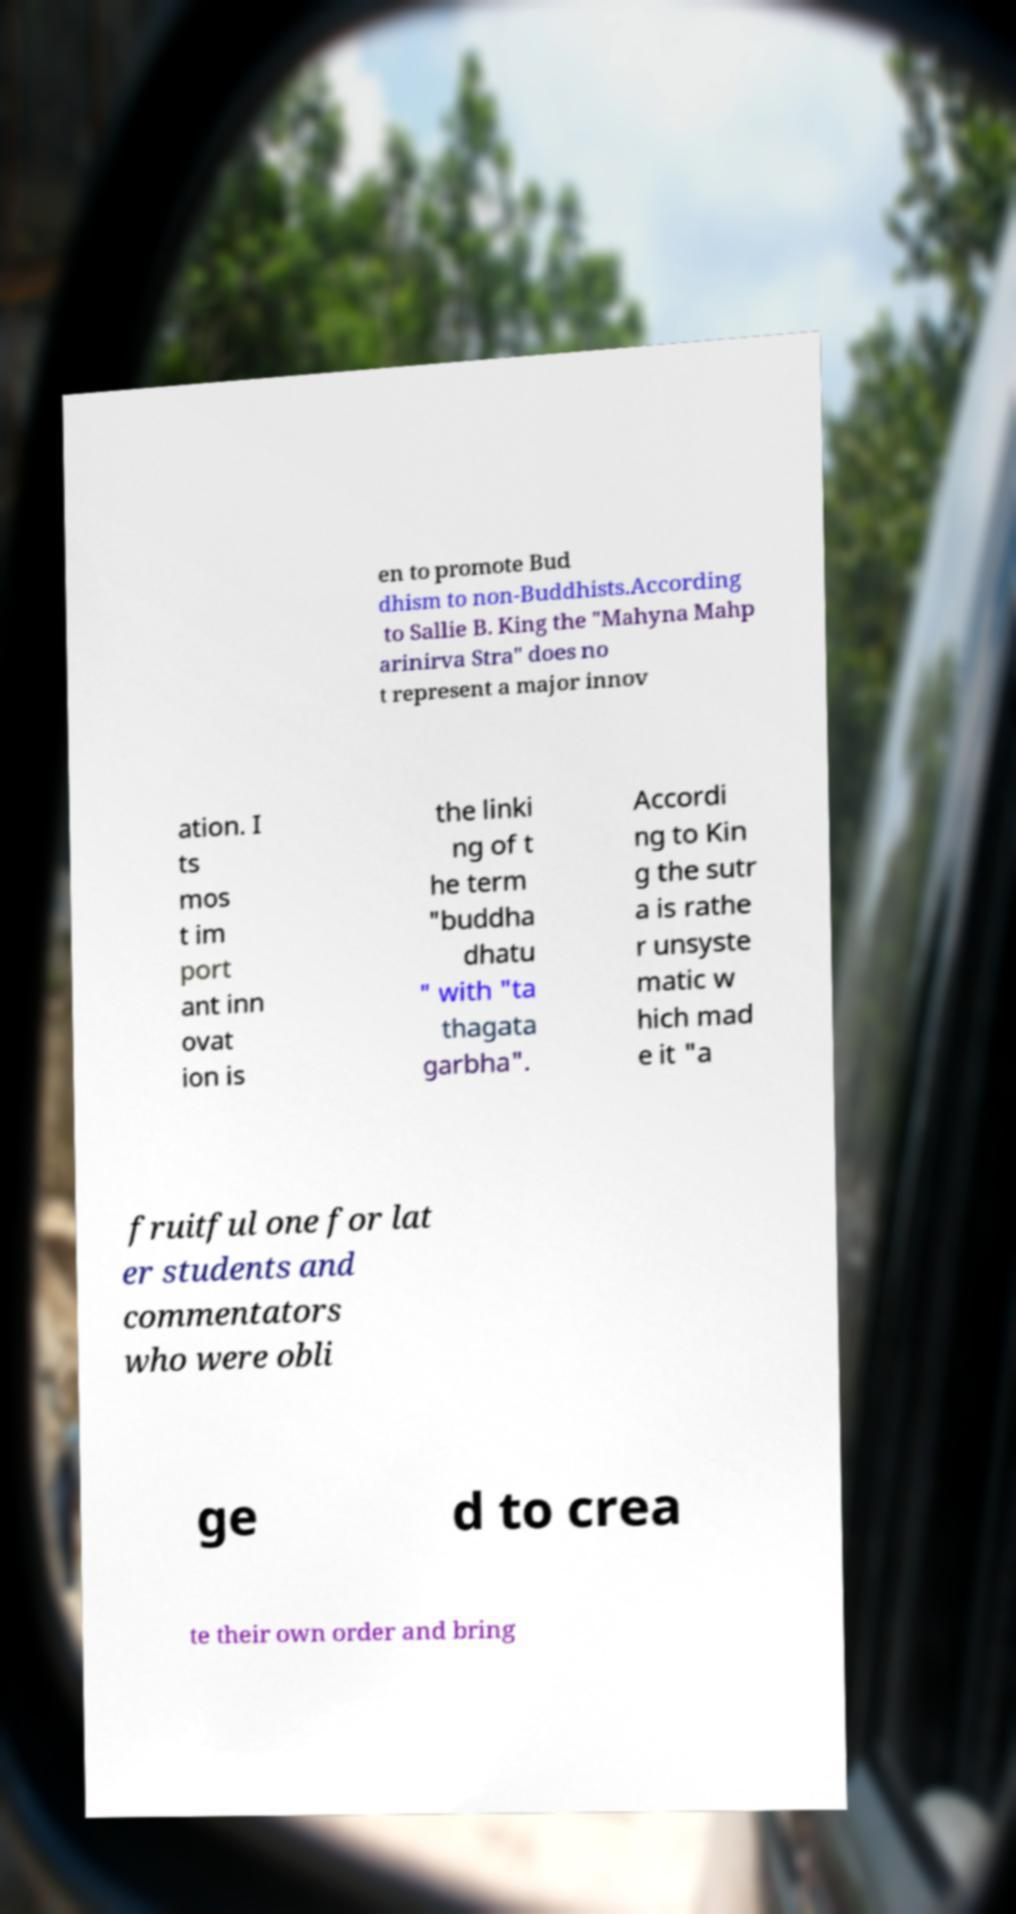There's text embedded in this image that I need extracted. Can you transcribe it verbatim? en to promote Bud dhism to non-Buddhists.According to Sallie B. King the "Mahyna Mahp arinirva Stra" does no t represent a major innov ation. I ts mos t im port ant inn ovat ion is the linki ng of t he term "buddha dhatu " with "ta thagata garbha". Accordi ng to Kin g the sutr a is rathe r unsyste matic w hich mad e it "a fruitful one for lat er students and commentators who were obli ge d to crea te their own order and bring 